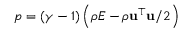<formula> <loc_0><loc_0><loc_500><loc_500>p = ( \gamma - 1 ) \left ( \rho E - \rho u ^ { \top } u / 2 \right )</formula> 